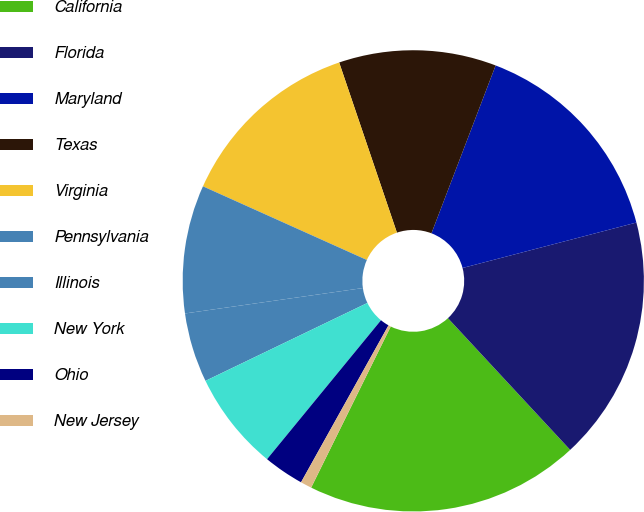<chart> <loc_0><loc_0><loc_500><loc_500><pie_chart><fcel>California<fcel>Florida<fcel>Maryland<fcel>Texas<fcel>Virginia<fcel>Pennsylvania<fcel>Illinois<fcel>New York<fcel>Ohio<fcel>New Jersey<nl><fcel>19.21%<fcel>17.16%<fcel>15.12%<fcel>11.02%<fcel>13.07%<fcel>8.98%<fcel>4.88%<fcel>6.93%<fcel>2.84%<fcel>0.79%<nl></chart> 